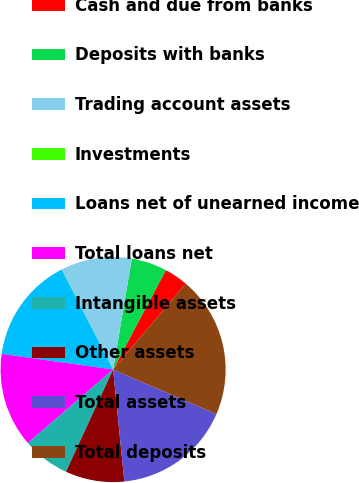<chart> <loc_0><loc_0><loc_500><loc_500><pie_chart><fcel>Cash and due from banks<fcel>Deposits with banks<fcel>Trading account assets<fcel>Investments<fcel>Loans net of unearned income<fcel>Total loans net<fcel>Intangible assets<fcel>Other assets<fcel>Total assets<fcel>Total deposits<nl><fcel>3.42%<fcel>5.1%<fcel>10.17%<fcel>0.04%<fcel>15.23%<fcel>13.55%<fcel>6.79%<fcel>8.48%<fcel>16.92%<fcel>20.3%<nl></chart> 